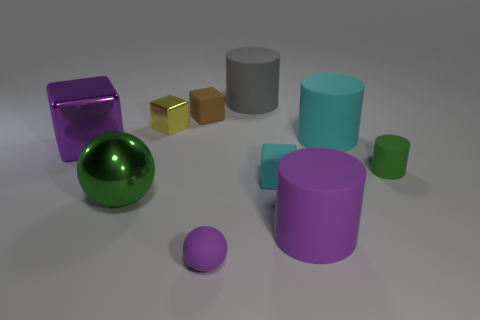How do the colors in the image contribute to its overall appearance? The colors in the image contribute significantly to its visual appeal. The contrast between the glossy purple and green objects and the matte surfaces of the grey cylinder and bronze cube creates a dynamic interplay of reflections and textures. The muted background ensures that the vibrant colors of the objects stand out, drawing attention to their forms and material properties. 